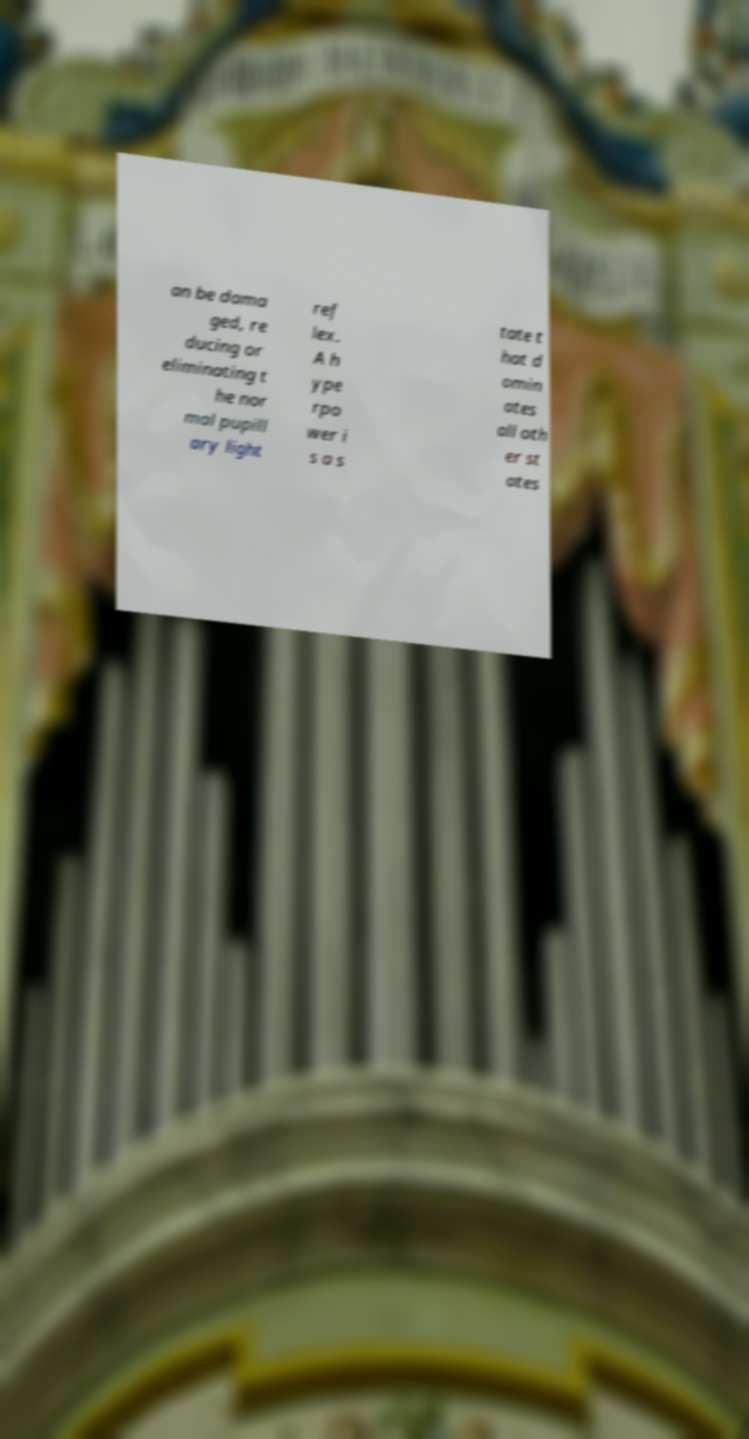For documentation purposes, I need the text within this image transcribed. Could you provide that? an be dama ged, re ducing or eliminating t he nor mal pupill ary light ref lex. A h ype rpo wer i s a s tate t hat d omin ates all oth er st ates 